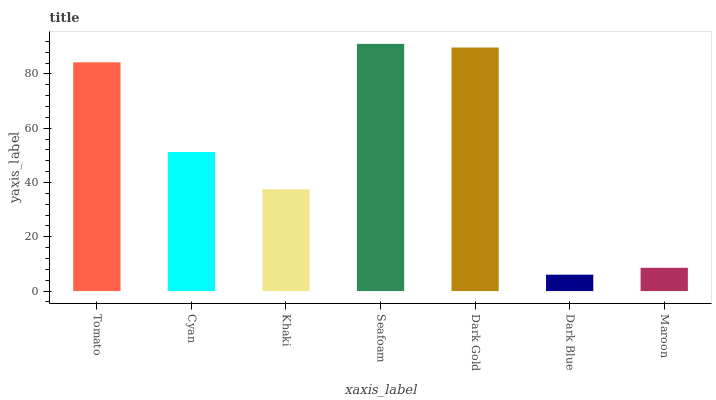Is Dark Blue the minimum?
Answer yes or no. Yes. Is Seafoam the maximum?
Answer yes or no. Yes. Is Cyan the minimum?
Answer yes or no. No. Is Cyan the maximum?
Answer yes or no. No. Is Tomato greater than Cyan?
Answer yes or no. Yes. Is Cyan less than Tomato?
Answer yes or no. Yes. Is Cyan greater than Tomato?
Answer yes or no. No. Is Tomato less than Cyan?
Answer yes or no. No. Is Cyan the high median?
Answer yes or no. Yes. Is Cyan the low median?
Answer yes or no. Yes. Is Dark Gold the high median?
Answer yes or no. No. Is Dark Blue the low median?
Answer yes or no. No. 